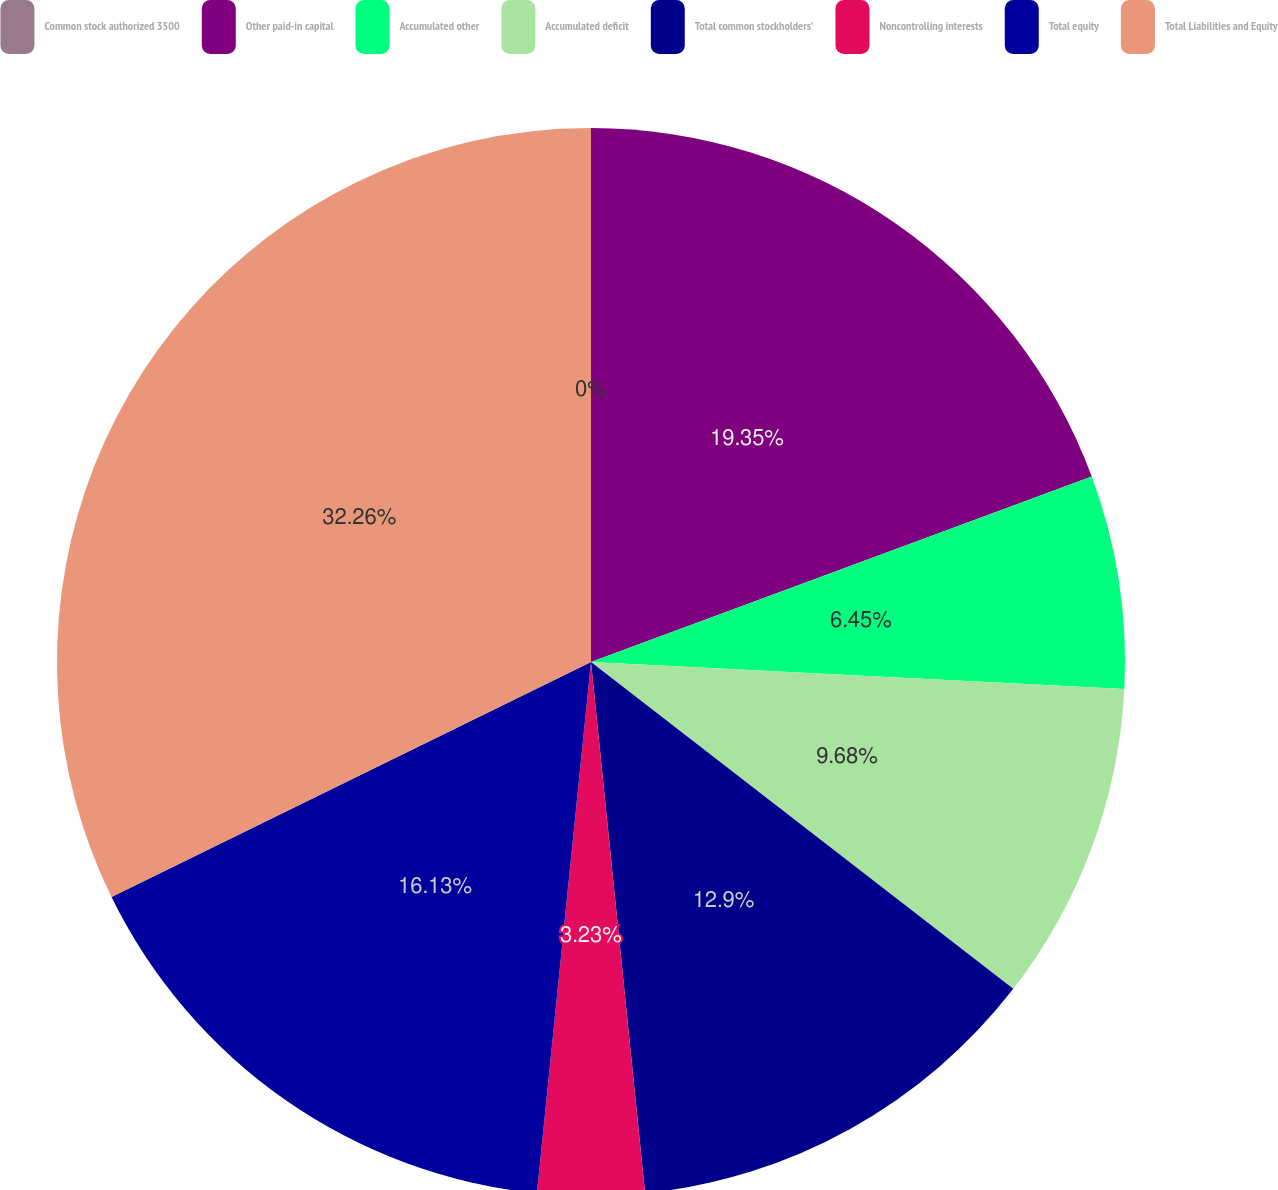Convert chart to OTSL. <chart><loc_0><loc_0><loc_500><loc_500><pie_chart><fcel>Common stock authorized 3500<fcel>Other paid-in capital<fcel>Accumulated other<fcel>Accumulated deficit<fcel>Total common stockholders'<fcel>Noncontrolling interests<fcel>Total equity<fcel>Total Liabilities and Equity<nl><fcel>0.0%<fcel>19.35%<fcel>6.45%<fcel>9.68%<fcel>12.9%<fcel>3.23%<fcel>16.13%<fcel>32.25%<nl></chart> 